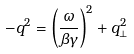<formula> <loc_0><loc_0><loc_500><loc_500>- q ^ { 2 } = \left ( \frac { \omega } { \beta \gamma } \right ) ^ { 2 } + q _ { \perp } ^ { 2 }</formula> 